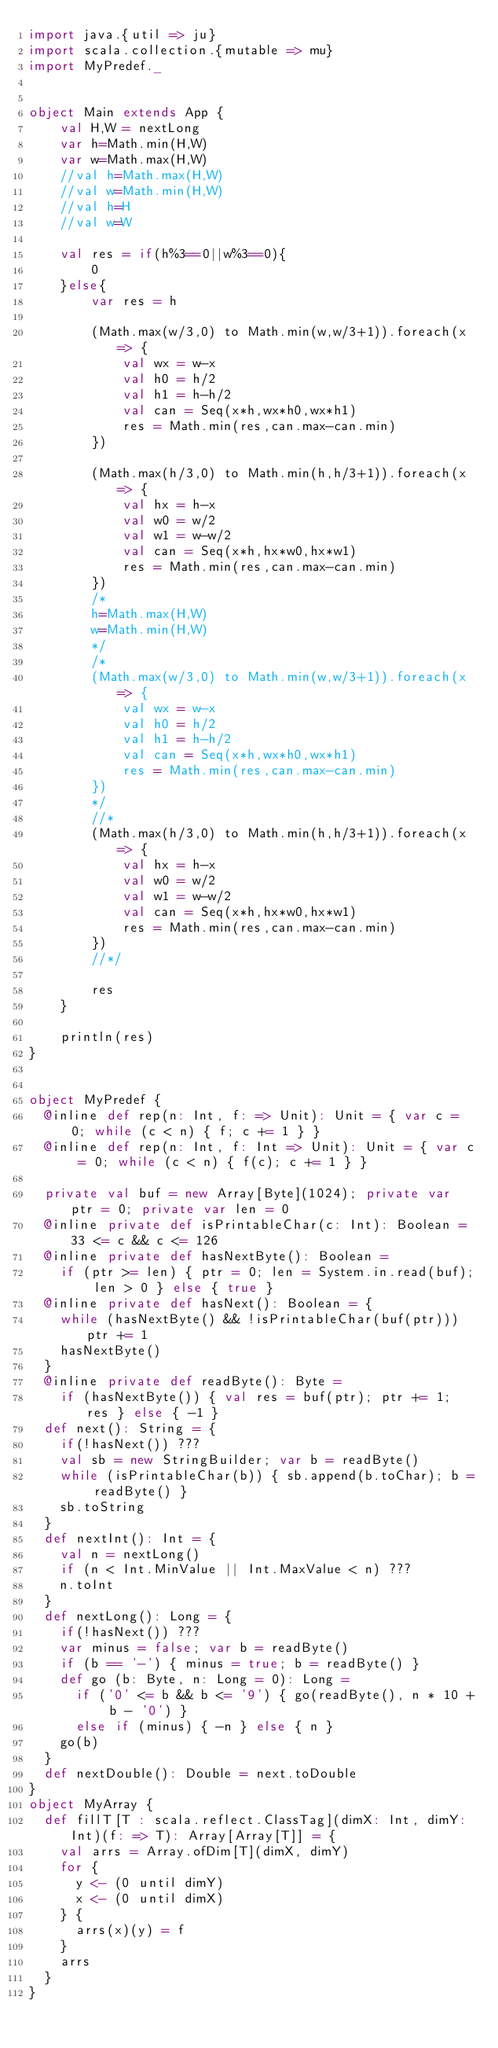Convert code to text. <code><loc_0><loc_0><loc_500><loc_500><_Scala_>import java.{util => ju}
import scala.collection.{mutable => mu}
import MyPredef._


object Main extends App {
    val H,W = nextLong
    var h=Math.min(H,W)
    var w=Math.max(H,W)
    //val h=Math.max(H,W)
    //val w=Math.min(H,W)
    //val h=H
    //val w=W
    
    val res = if(h%3==0||w%3==0){
        0
    }else{
        var res = h
        
        (Math.max(w/3,0) to Math.min(w,w/3+1)).foreach(x => {
            val wx = w-x
            val h0 = h/2
            val h1 = h-h/2
            val can = Seq(x*h,wx*h0,wx*h1)
            res = Math.min(res,can.max-can.min)
        })
         
        (Math.max(h/3,0) to Math.min(h,h/3+1)).foreach(x => {
            val hx = h-x
            val w0 = w/2
            val w1 = w-w/2
            val can = Seq(x*h,hx*w0,hx*w1)
            res = Math.min(res,can.max-can.min)
        })
        /*
        h=Math.max(H,W)
        w=Math.min(H,W)
        */
        /*
        (Math.max(w/3,0) to Math.min(w,w/3+1)).foreach(x => {
            val wx = w-x
            val h0 = h/2
            val h1 = h-h/2
            val can = Seq(x*h,wx*h0,wx*h1)
            res = Math.min(res,can.max-can.min)
        })
        */
        //*
        (Math.max(h/3,0) to Math.min(h,h/3+1)).foreach(x => {
            val hx = h-x
            val w0 = w/2
            val w1 = w-w/2
            val can = Seq(x*h,hx*w0,hx*w1)
            res = Math.min(res,can.max-can.min)
        })
        //*/
        
        res
    }
    
    println(res)
}


object MyPredef {
  @inline def rep(n: Int, f: => Unit): Unit = { var c = 0; while (c < n) { f; c += 1 } }
  @inline def rep(n: Int, f: Int => Unit): Unit = { var c = 0; while (c < n) { f(c); c += 1 } }

  private val buf = new Array[Byte](1024); private var ptr = 0; private var len = 0
  @inline private def isPrintableChar(c: Int): Boolean = 33 <= c && c <= 126
  @inline private def hasNextByte(): Boolean =
    if (ptr >= len) { ptr = 0; len = System.in.read(buf); len > 0 } else { true }
  @inline private def hasNext(): Boolean = {
    while (hasNextByte() && !isPrintableChar(buf(ptr))) ptr += 1
    hasNextByte()
  }
  @inline private def readByte(): Byte =
    if (hasNextByte()) { val res = buf(ptr); ptr += 1; res } else { -1 }
  def next(): String = {
    if(!hasNext()) ???
    val sb = new StringBuilder; var b = readByte()
    while (isPrintableChar(b)) { sb.append(b.toChar); b = readByte() }
    sb.toString
  }
  def nextInt(): Int = {
    val n = nextLong()
    if (n < Int.MinValue || Int.MaxValue < n) ???
    n.toInt
  }
  def nextLong(): Long = {
    if(!hasNext()) ???
    var minus = false; var b = readByte()
    if (b == '-') { minus = true; b = readByte() }
    def go (b: Byte, n: Long = 0): Long =
      if ('0' <= b && b <= '9') { go(readByte(), n * 10 + b - '0') }
      else if (minus) { -n } else { n }
    go(b)
  }
  def nextDouble(): Double = next.toDouble
}
object MyArray {
  def fillT[T : scala.reflect.ClassTag](dimX: Int, dimY: Int)(f: => T): Array[Array[T]] = {
    val arrs = Array.ofDim[T](dimX, dimY)
    for {
      y <- (0 until dimY)
      x <- (0 until dimX)
    } {
      arrs(x)(y) = f
    }
    arrs
  }
}</code> 